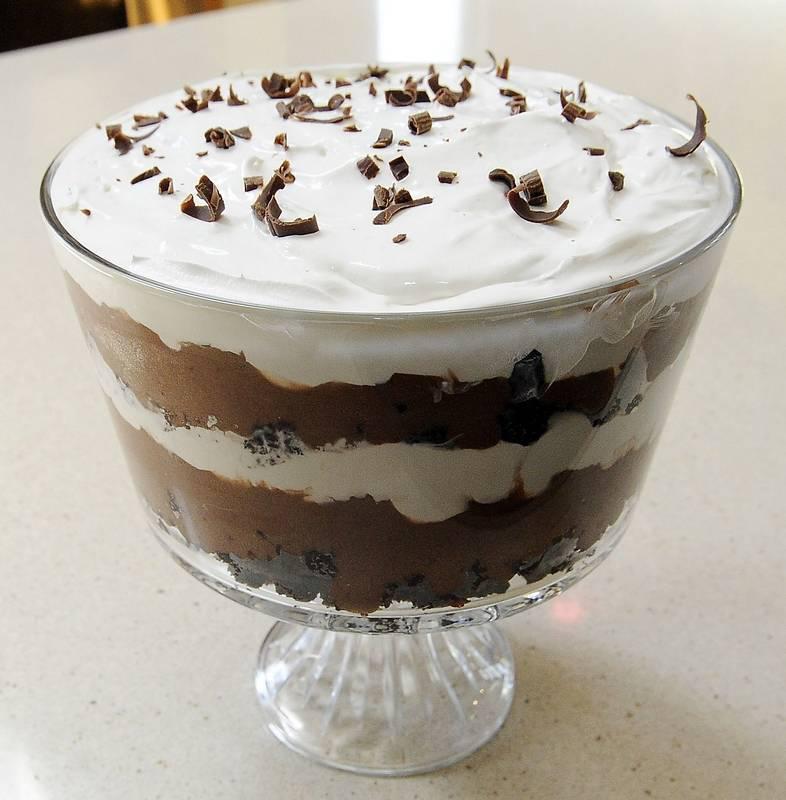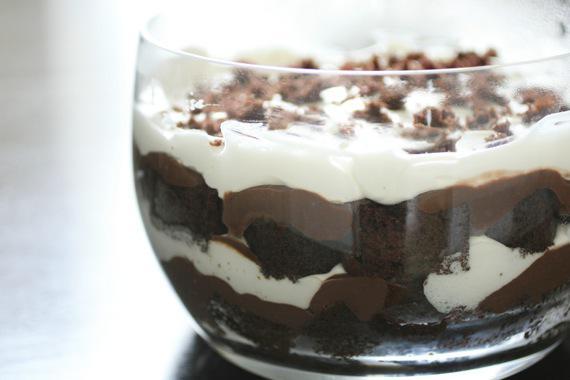The first image is the image on the left, the second image is the image on the right. Considering the images on both sides, is "One of the images displays the entire serving container." valid? Answer yes or no. Yes. 